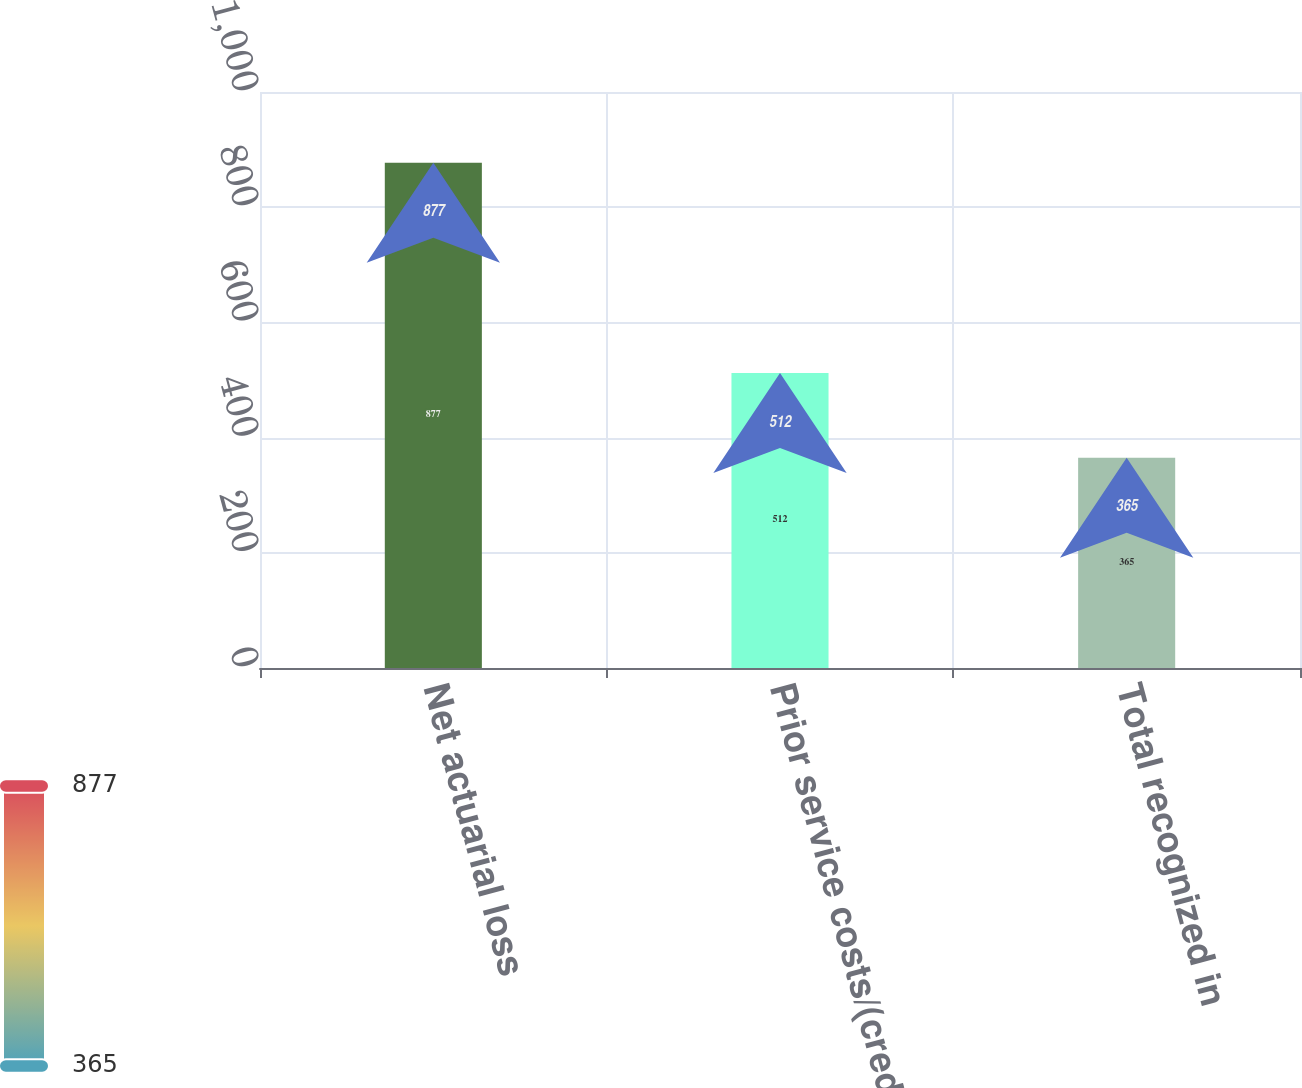Convert chart. <chart><loc_0><loc_0><loc_500><loc_500><bar_chart><fcel>Net actuarial loss<fcel>Prior service costs/(credits)<fcel>Total recognized in<nl><fcel>877<fcel>512<fcel>365<nl></chart> 